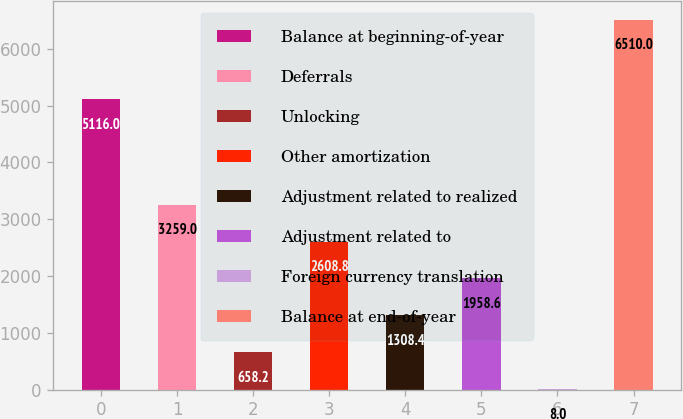Convert chart. <chart><loc_0><loc_0><loc_500><loc_500><bar_chart><fcel>Balance at beginning-of-year<fcel>Deferrals<fcel>Unlocking<fcel>Other amortization<fcel>Adjustment related to realized<fcel>Adjustment related to<fcel>Foreign currency translation<fcel>Balance at end-of-year<nl><fcel>5116<fcel>3259<fcel>658.2<fcel>2608.8<fcel>1308.4<fcel>1958.6<fcel>8<fcel>6510<nl></chart> 